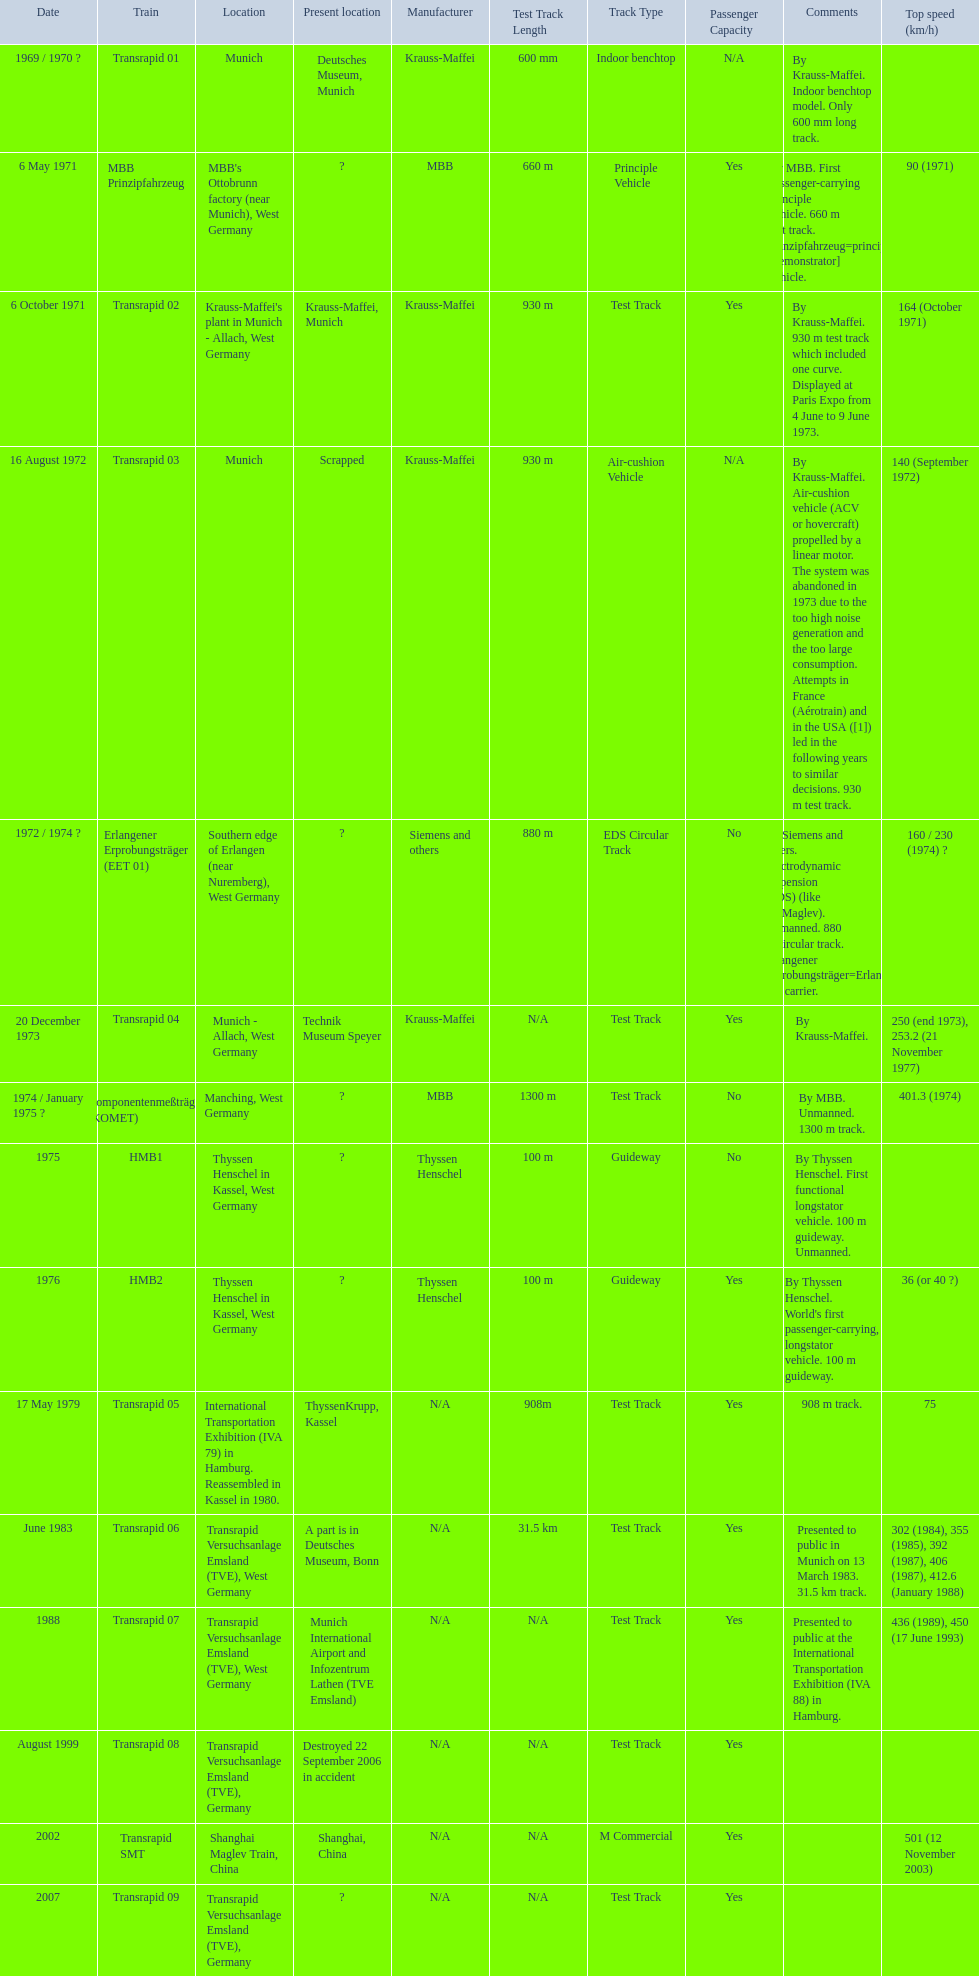What are the names of each transrapid train? Transrapid 01, MBB Prinzipfahrzeug, Transrapid 02, Transrapid 03, Erlangener Erprobungsträger (EET 01), Transrapid 04, Komponentenmeßträger (KOMET), HMB1, HMB2, Transrapid 05, Transrapid 06, Transrapid 07, Transrapid 08, Transrapid SMT, Transrapid 09. What are their listed top speeds? 90 (1971), 164 (October 1971), 140 (September 1972), 160 / 230 (1974) ?, 250 (end 1973), 253.2 (21 November 1977), 401.3 (1974), 36 (or 40 ?), 75, 302 (1984), 355 (1985), 392 (1987), 406 (1987), 412.6 (January 1988), 436 (1989), 450 (17 June 1993), 501 (12 November 2003). And which train operates at the fastest speed? Transrapid SMT. 